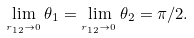Convert formula to latex. <formula><loc_0><loc_0><loc_500><loc_500>\lim _ { _ { r _ { 1 2 } \rightarrow 0 } } \theta _ { 1 } = \lim _ { _ { r _ { 1 2 } \rightarrow 0 } } \theta _ { 2 } = \pi / 2 .</formula> 